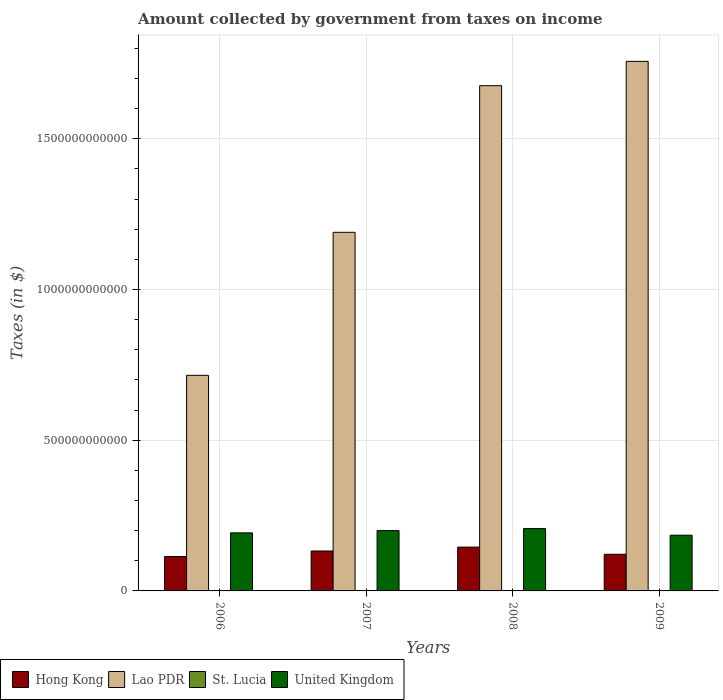How many groups of bars are there?
Offer a terse response. 4. How many bars are there on the 4th tick from the left?
Provide a short and direct response. 4. How many bars are there on the 1st tick from the right?
Make the answer very short. 4. What is the label of the 1st group of bars from the left?
Your answer should be compact. 2006. In how many cases, is the number of bars for a given year not equal to the number of legend labels?
Your answer should be compact. 0. What is the amount collected by government from taxes on income in Hong Kong in 2007?
Your answer should be compact. 1.32e+11. Across all years, what is the maximum amount collected by government from taxes on income in United Kingdom?
Make the answer very short. 2.07e+11. Across all years, what is the minimum amount collected by government from taxes on income in United Kingdom?
Provide a short and direct response. 1.85e+11. In which year was the amount collected by government from taxes on income in St. Lucia maximum?
Your response must be concise. 2009. In which year was the amount collected by government from taxes on income in United Kingdom minimum?
Your response must be concise. 2009. What is the total amount collected by government from taxes on income in Hong Kong in the graph?
Provide a succinct answer. 5.13e+11. What is the difference between the amount collected by government from taxes on income in United Kingdom in 2007 and that in 2008?
Keep it short and to the point. -6.88e+09. What is the difference between the amount collected by government from taxes on income in Lao PDR in 2007 and the amount collected by government from taxes on income in United Kingdom in 2009?
Make the answer very short. 1.00e+12. What is the average amount collected by government from taxes on income in Hong Kong per year?
Your answer should be very brief. 1.28e+11. In the year 2008, what is the difference between the amount collected by government from taxes on income in Lao PDR and amount collected by government from taxes on income in United Kingdom?
Provide a succinct answer. 1.47e+12. What is the ratio of the amount collected by government from taxes on income in Hong Kong in 2007 to that in 2009?
Your answer should be compact. 1.09. Is the amount collected by government from taxes on income in United Kingdom in 2006 less than that in 2007?
Your response must be concise. Yes. Is the difference between the amount collected by government from taxes on income in Lao PDR in 2006 and 2007 greater than the difference between the amount collected by government from taxes on income in United Kingdom in 2006 and 2007?
Ensure brevity in your answer.  No. What is the difference between the highest and the second highest amount collected by government from taxes on income in United Kingdom?
Your answer should be compact. 6.88e+09. What is the difference between the highest and the lowest amount collected by government from taxes on income in St. Lucia?
Your answer should be compact. 7.79e+07. In how many years, is the amount collected by government from taxes on income in St. Lucia greater than the average amount collected by government from taxes on income in St. Lucia taken over all years?
Your answer should be compact. 2. What does the 1st bar from the left in 2006 represents?
Provide a short and direct response. Hong Kong. What does the 2nd bar from the right in 2007 represents?
Offer a terse response. St. Lucia. Is it the case that in every year, the sum of the amount collected by government from taxes on income in St. Lucia and amount collected by government from taxes on income in United Kingdom is greater than the amount collected by government from taxes on income in Lao PDR?
Give a very brief answer. No. How many bars are there?
Offer a terse response. 16. How many years are there in the graph?
Your answer should be compact. 4. What is the difference between two consecutive major ticks on the Y-axis?
Give a very brief answer. 5.00e+11. Are the values on the major ticks of Y-axis written in scientific E-notation?
Keep it short and to the point. No. Does the graph contain grids?
Make the answer very short. Yes. Where does the legend appear in the graph?
Offer a terse response. Bottom left. How are the legend labels stacked?
Your answer should be compact. Horizontal. What is the title of the graph?
Your answer should be very brief. Amount collected by government from taxes on income. Does "Maldives" appear as one of the legend labels in the graph?
Your response must be concise. No. What is the label or title of the Y-axis?
Provide a succinct answer. Taxes (in $). What is the Taxes (in $) of Hong Kong in 2006?
Give a very brief answer. 1.14e+11. What is the Taxes (in $) in Lao PDR in 2006?
Give a very brief answer. 7.15e+11. What is the Taxes (in $) in St. Lucia in 2006?
Provide a short and direct response. 1.48e+08. What is the Taxes (in $) in United Kingdom in 2006?
Your response must be concise. 1.93e+11. What is the Taxes (in $) of Hong Kong in 2007?
Your answer should be very brief. 1.32e+11. What is the Taxes (in $) of Lao PDR in 2007?
Offer a very short reply. 1.19e+12. What is the Taxes (in $) of St. Lucia in 2007?
Provide a short and direct response. 1.77e+08. What is the Taxes (in $) in United Kingdom in 2007?
Keep it short and to the point. 2.00e+11. What is the Taxes (in $) in Hong Kong in 2008?
Your answer should be very brief. 1.45e+11. What is the Taxes (in $) of Lao PDR in 2008?
Keep it short and to the point. 1.68e+12. What is the Taxes (in $) in St. Lucia in 2008?
Keep it short and to the point. 2.26e+08. What is the Taxes (in $) of United Kingdom in 2008?
Ensure brevity in your answer.  2.07e+11. What is the Taxes (in $) in Hong Kong in 2009?
Ensure brevity in your answer.  1.22e+11. What is the Taxes (in $) in Lao PDR in 2009?
Your response must be concise. 1.76e+12. What is the Taxes (in $) in St. Lucia in 2009?
Ensure brevity in your answer.  2.26e+08. What is the Taxes (in $) of United Kingdom in 2009?
Your answer should be compact. 1.85e+11. Across all years, what is the maximum Taxes (in $) of Hong Kong?
Your answer should be compact. 1.45e+11. Across all years, what is the maximum Taxes (in $) in Lao PDR?
Your response must be concise. 1.76e+12. Across all years, what is the maximum Taxes (in $) of St. Lucia?
Give a very brief answer. 2.26e+08. Across all years, what is the maximum Taxes (in $) in United Kingdom?
Offer a very short reply. 2.07e+11. Across all years, what is the minimum Taxes (in $) in Hong Kong?
Offer a very short reply. 1.14e+11. Across all years, what is the minimum Taxes (in $) of Lao PDR?
Keep it short and to the point. 7.15e+11. Across all years, what is the minimum Taxes (in $) in St. Lucia?
Provide a short and direct response. 1.48e+08. Across all years, what is the minimum Taxes (in $) in United Kingdom?
Offer a terse response. 1.85e+11. What is the total Taxes (in $) in Hong Kong in the graph?
Provide a short and direct response. 5.13e+11. What is the total Taxes (in $) in Lao PDR in the graph?
Provide a succinct answer. 5.34e+12. What is the total Taxes (in $) of St. Lucia in the graph?
Keep it short and to the point. 7.77e+08. What is the total Taxes (in $) of United Kingdom in the graph?
Offer a very short reply. 7.84e+11. What is the difference between the Taxes (in $) of Hong Kong in 2006 and that in 2007?
Your response must be concise. -1.84e+1. What is the difference between the Taxes (in $) of Lao PDR in 2006 and that in 2007?
Provide a succinct answer. -4.74e+11. What is the difference between the Taxes (in $) of St. Lucia in 2006 and that in 2007?
Provide a succinct answer. -2.82e+07. What is the difference between the Taxes (in $) of United Kingdom in 2006 and that in 2007?
Give a very brief answer. -7.44e+09. What is the difference between the Taxes (in $) in Hong Kong in 2006 and that in 2008?
Make the answer very short. -3.12e+1. What is the difference between the Taxes (in $) of Lao PDR in 2006 and that in 2008?
Ensure brevity in your answer.  -9.61e+11. What is the difference between the Taxes (in $) in St. Lucia in 2006 and that in 2008?
Ensure brevity in your answer.  -7.73e+07. What is the difference between the Taxes (in $) of United Kingdom in 2006 and that in 2008?
Provide a short and direct response. -1.43e+1. What is the difference between the Taxes (in $) in Hong Kong in 2006 and that in 2009?
Make the answer very short. -7.44e+09. What is the difference between the Taxes (in $) in Lao PDR in 2006 and that in 2009?
Provide a succinct answer. -1.04e+12. What is the difference between the Taxes (in $) of St. Lucia in 2006 and that in 2009?
Make the answer very short. -7.79e+07. What is the difference between the Taxes (in $) of United Kingdom in 2006 and that in 2009?
Ensure brevity in your answer.  7.80e+09. What is the difference between the Taxes (in $) of Hong Kong in 2007 and that in 2008?
Keep it short and to the point. -1.28e+1. What is the difference between the Taxes (in $) in Lao PDR in 2007 and that in 2008?
Make the answer very short. -4.86e+11. What is the difference between the Taxes (in $) in St. Lucia in 2007 and that in 2008?
Provide a succinct answer. -4.91e+07. What is the difference between the Taxes (in $) in United Kingdom in 2007 and that in 2008?
Provide a short and direct response. -6.88e+09. What is the difference between the Taxes (in $) of Hong Kong in 2007 and that in 2009?
Your response must be concise. 1.10e+1. What is the difference between the Taxes (in $) in Lao PDR in 2007 and that in 2009?
Your response must be concise. -5.67e+11. What is the difference between the Taxes (in $) in St. Lucia in 2007 and that in 2009?
Provide a succinct answer. -4.97e+07. What is the difference between the Taxes (in $) in United Kingdom in 2007 and that in 2009?
Your response must be concise. 1.52e+1. What is the difference between the Taxes (in $) in Hong Kong in 2008 and that in 2009?
Give a very brief answer. 2.38e+1. What is the difference between the Taxes (in $) in Lao PDR in 2008 and that in 2009?
Make the answer very short. -8.07e+1. What is the difference between the Taxes (in $) of St. Lucia in 2008 and that in 2009?
Provide a succinct answer. -6.00e+05. What is the difference between the Taxes (in $) in United Kingdom in 2008 and that in 2009?
Your response must be concise. 2.21e+1. What is the difference between the Taxes (in $) in Hong Kong in 2006 and the Taxes (in $) in Lao PDR in 2007?
Provide a short and direct response. -1.08e+12. What is the difference between the Taxes (in $) of Hong Kong in 2006 and the Taxes (in $) of St. Lucia in 2007?
Ensure brevity in your answer.  1.14e+11. What is the difference between the Taxes (in $) in Hong Kong in 2006 and the Taxes (in $) in United Kingdom in 2007?
Provide a succinct answer. -8.60e+1. What is the difference between the Taxes (in $) of Lao PDR in 2006 and the Taxes (in $) of St. Lucia in 2007?
Offer a terse response. 7.15e+11. What is the difference between the Taxes (in $) in Lao PDR in 2006 and the Taxes (in $) in United Kingdom in 2007?
Your answer should be very brief. 5.15e+11. What is the difference between the Taxes (in $) of St. Lucia in 2006 and the Taxes (in $) of United Kingdom in 2007?
Make the answer very short. -2.00e+11. What is the difference between the Taxes (in $) of Hong Kong in 2006 and the Taxes (in $) of Lao PDR in 2008?
Your answer should be compact. -1.56e+12. What is the difference between the Taxes (in $) of Hong Kong in 2006 and the Taxes (in $) of St. Lucia in 2008?
Keep it short and to the point. 1.14e+11. What is the difference between the Taxes (in $) in Hong Kong in 2006 and the Taxes (in $) in United Kingdom in 2008?
Offer a terse response. -9.28e+1. What is the difference between the Taxes (in $) in Lao PDR in 2006 and the Taxes (in $) in St. Lucia in 2008?
Your answer should be compact. 7.15e+11. What is the difference between the Taxes (in $) of Lao PDR in 2006 and the Taxes (in $) of United Kingdom in 2008?
Your response must be concise. 5.08e+11. What is the difference between the Taxes (in $) in St. Lucia in 2006 and the Taxes (in $) in United Kingdom in 2008?
Offer a very short reply. -2.07e+11. What is the difference between the Taxes (in $) of Hong Kong in 2006 and the Taxes (in $) of Lao PDR in 2009?
Make the answer very short. -1.64e+12. What is the difference between the Taxes (in $) in Hong Kong in 2006 and the Taxes (in $) in St. Lucia in 2009?
Provide a succinct answer. 1.14e+11. What is the difference between the Taxes (in $) of Hong Kong in 2006 and the Taxes (in $) of United Kingdom in 2009?
Keep it short and to the point. -7.07e+1. What is the difference between the Taxes (in $) of Lao PDR in 2006 and the Taxes (in $) of St. Lucia in 2009?
Provide a short and direct response. 7.15e+11. What is the difference between the Taxes (in $) of Lao PDR in 2006 and the Taxes (in $) of United Kingdom in 2009?
Make the answer very short. 5.30e+11. What is the difference between the Taxes (in $) of St. Lucia in 2006 and the Taxes (in $) of United Kingdom in 2009?
Keep it short and to the point. -1.85e+11. What is the difference between the Taxes (in $) in Hong Kong in 2007 and the Taxes (in $) in Lao PDR in 2008?
Ensure brevity in your answer.  -1.54e+12. What is the difference between the Taxes (in $) in Hong Kong in 2007 and the Taxes (in $) in St. Lucia in 2008?
Your answer should be very brief. 1.32e+11. What is the difference between the Taxes (in $) of Hong Kong in 2007 and the Taxes (in $) of United Kingdom in 2008?
Keep it short and to the point. -7.44e+1. What is the difference between the Taxes (in $) of Lao PDR in 2007 and the Taxes (in $) of St. Lucia in 2008?
Offer a terse response. 1.19e+12. What is the difference between the Taxes (in $) of Lao PDR in 2007 and the Taxes (in $) of United Kingdom in 2008?
Make the answer very short. 9.83e+11. What is the difference between the Taxes (in $) of St. Lucia in 2007 and the Taxes (in $) of United Kingdom in 2008?
Provide a succinct answer. -2.07e+11. What is the difference between the Taxes (in $) of Hong Kong in 2007 and the Taxes (in $) of Lao PDR in 2009?
Provide a short and direct response. -1.62e+12. What is the difference between the Taxes (in $) in Hong Kong in 2007 and the Taxes (in $) in St. Lucia in 2009?
Ensure brevity in your answer.  1.32e+11. What is the difference between the Taxes (in $) in Hong Kong in 2007 and the Taxes (in $) in United Kingdom in 2009?
Make the answer very short. -5.23e+1. What is the difference between the Taxes (in $) of Lao PDR in 2007 and the Taxes (in $) of St. Lucia in 2009?
Offer a very short reply. 1.19e+12. What is the difference between the Taxes (in $) in Lao PDR in 2007 and the Taxes (in $) in United Kingdom in 2009?
Make the answer very short. 1.00e+12. What is the difference between the Taxes (in $) in St. Lucia in 2007 and the Taxes (in $) in United Kingdom in 2009?
Your answer should be compact. -1.85e+11. What is the difference between the Taxes (in $) in Hong Kong in 2008 and the Taxes (in $) in Lao PDR in 2009?
Make the answer very short. -1.61e+12. What is the difference between the Taxes (in $) in Hong Kong in 2008 and the Taxes (in $) in St. Lucia in 2009?
Your response must be concise. 1.45e+11. What is the difference between the Taxes (in $) of Hong Kong in 2008 and the Taxes (in $) of United Kingdom in 2009?
Make the answer very short. -3.95e+1. What is the difference between the Taxes (in $) of Lao PDR in 2008 and the Taxes (in $) of St. Lucia in 2009?
Keep it short and to the point. 1.68e+12. What is the difference between the Taxes (in $) in Lao PDR in 2008 and the Taxes (in $) in United Kingdom in 2009?
Your answer should be very brief. 1.49e+12. What is the difference between the Taxes (in $) of St. Lucia in 2008 and the Taxes (in $) of United Kingdom in 2009?
Your answer should be compact. -1.85e+11. What is the average Taxes (in $) in Hong Kong per year?
Provide a succinct answer. 1.28e+11. What is the average Taxes (in $) in Lao PDR per year?
Make the answer very short. 1.33e+12. What is the average Taxes (in $) in St. Lucia per year?
Your answer should be very brief. 1.94e+08. What is the average Taxes (in $) in United Kingdom per year?
Make the answer very short. 1.96e+11. In the year 2006, what is the difference between the Taxes (in $) in Hong Kong and Taxes (in $) in Lao PDR?
Your answer should be compact. -6.01e+11. In the year 2006, what is the difference between the Taxes (in $) in Hong Kong and Taxes (in $) in St. Lucia?
Your response must be concise. 1.14e+11. In the year 2006, what is the difference between the Taxes (in $) in Hong Kong and Taxes (in $) in United Kingdom?
Your response must be concise. -7.85e+1. In the year 2006, what is the difference between the Taxes (in $) in Lao PDR and Taxes (in $) in St. Lucia?
Offer a terse response. 7.15e+11. In the year 2006, what is the difference between the Taxes (in $) of Lao PDR and Taxes (in $) of United Kingdom?
Make the answer very short. 5.23e+11. In the year 2006, what is the difference between the Taxes (in $) in St. Lucia and Taxes (in $) in United Kingdom?
Keep it short and to the point. -1.92e+11. In the year 2007, what is the difference between the Taxes (in $) in Hong Kong and Taxes (in $) in Lao PDR?
Your answer should be compact. -1.06e+12. In the year 2007, what is the difference between the Taxes (in $) of Hong Kong and Taxes (in $) of St. Lucia?
Your answer should be compact. 1.32e+11. In the year 2007, what is the difference between the Taxes (in $) in Hong Kong and Taxes (in $) in United Kingdom?
Offer a very short reply. -6.76e+1. In the year 2007, what is the difference between the Taxes (in $) of Lao PDR and Taxes (in $) of St. Lucia?
Provide a short and direct response. 1.19e+12. In the year 2007, what is the difference between the Taxes (in $) of Lao PDR and Taxes (in $) of United Kingdom?
Your response must be concise. 9.90e+11. In the year 2007, what is the difference between the Taxes (in $) of St. Lucia and Taxes (in $) of United Kingdom?
Your response must be concise. -2.00e+11. In the year 2008, what is the difference between the Taxes (in $) in Hong Kong and Taxes (in $) in Lao PDR?
Your answer should be compact. -1.53e+12. In the year 2008, what is the difference between the Taxes (in $) of Hong Kong and Taxes (in $) of St. Lucia?
Provide a succinct answer. 1.45e+11. In the year 2008, what is the difference between the Taxes (in $) in Hong Kong and Taxes (in $) in United Kingdom?
Give a very brief answer. -6.16e+1. In the year 2008, what is the difference between the Taxes (in $) of Lao PDR and Taxes (in $) of St. Lucia?
Your answer should be very brief. 1.68e+12. In the year 2008, what is the difference between the Taxes (in $) of Lao PDR and Taxes (in $) of United Kingdom?
Your answer should be very brief. 1.47e+12. In the year 2008, what is the difference between the Taxes (in $) in St. Lucia and Taxes (in $) in United Kingdom?
Your answer should be very brief. -2.07e+11. In the year 2009, what is the difference between the Taxes (in $) in Hong Kong and Taxes (in $) in Lao PDR?
Provide a succinct answer. -1.64e+12. In the year 2009, what is the difference between the Taxes (in $) of Hong Kong and Taxes (in $) of St. Lucia?
Ensure brevity in your answer.  1.21e+11. In the year 2009, what is the difference between the Taxes (in $) in Hong Kong and Taxes (in $) in United Kingdom?
Offer a very short reply. -6.33e+1. In the year 2009, what is the difference between the Taxes (in $) of Lao PDR and Taxes (in $) of St. Lucia?
Your answer should be very brief. 1.76e+12. In the year 2009, what is the difference between the Taxes (in $) in Lao PDR and Taxes (in $) in United Kingdom?
Give a very brief answer. 1.57e+12. In the year 2009, what is the difference between the Taxes (in $) in St. Lucia and Taxes (in $) in United Kingdom?
Ensure brevity in your answer.  -1.85e+11. What is the ratio of the Taxes (in $) in Hong Kong in 2006 to that in 2007?
Provide a succinct answer. 0.86. What is the ratio of the Taxes (in $) of Lao PDR in 2006 to that in 2007?
Give a very brief answer. 0.6. What is the ratio of the Taxes (in $) in St. Lucia in 2006 to that in 2007?
Make the answer very short. 0.84. What is the ratio of the Taxes (in $) of United Kingdom in 2006 to that in 2007?
Your response must be concise. 0.96. What is the ratio of the Taxes (in $) in Hong Kong in 2006 to that in 2008?
Offer a very short reply. 0.78. What is the ratio of the Taxes (in $) of Lao PDR in 2006 to that in 2008?
Give a very brief answer. 0.43. What is the ratio of the Taxes (in $) in St. Lucia in 2006 to that in 2008?
Your answer should be very brief. 0.66. What is the ratio of the Taxes (in $) of United Kingdom in 2006 to that in 2008?
Offer a terse response. 0.93. What is the ratio of the Taxes (in $) in Hong Kong in 2006 to that in 2009?
Make the answer very short. 0.94. What is the ratio of the Taxes (in $) in Lao PDR in 2006 to that in 2009?
Provide a short and direct response. 0.41. What is the ratio of the Taxes (in $) of St. Lucia in 2006 to that in 2009?
Ensure brevity in your answer.  0.66. What is the ratio of the Taxes (in $) in United Kingdom in 2006 to that in 2009?
Make the answer very short. 1.04. What is the ratio of the Taxes (in $) in Hong Kong in 2007 to that in 2008?
Keep it short and to the point. 0.91. What is the ratio of the Taxes (in $) in Lao PDR in 2007 to that in 2008?
Offer a terse response. 0.71. What is the ratio of the Taxes (in $) of St. Lucia in 2007 to that in 2008?
Offer a very short reply. 0.78. What is the ratio of the Taxes (in $) in United Kingdom in 2007 to that in 2008?
Provide a short and direct response. 0.97. What is the ratio of the Taxes (in $) of Hong Kong in 2007 to that in 2009?
Provide a succinct answer. 1.09. What is the ratio of the Taxes (in $) in Lao PDR in 2007 to that in 2009?
Make the answer very short. 0.68. What is the ratio of the Taxes (in $) of St. Lucia in 2007 to that in 2009?
Ensure brevity in your answer.  0.78. What is the ratio of the Taxes (in $) in United Kingdom in 2007 to that in 2009?
Keep it short and to the point. 1.08. What is the ratio of the Taxes (in $) in Hong Kong in 2008 to that in 2009?
Make the answer very short. 1.2. What is the ratio of the Taxes (in $) of Lao PDR in 2008 to that in 2009?
Provide a short and direct response. 0.95. What is the ratio of the Taxes (in $) of St. Lucia in 2008 to that in 2009?
Offer a very short reply. 1. What is the ratio of the Taxes (in $) in United Kingdom in 2008 to that in 2009?
Make the answer very short. 1.12. What is the difference between the highest and the second highest Taxes (in $) in Hong Kong?
Offer a very short reply. 1.28e+1. What is the difference between the highest and the second highest Taxes (in $) of Lao PDR?
Provide a short and direct response. 8.07e+1. What is the difference between the highest and the second highest Taxes (in $) of St. Lucia?
Provide a succinct answer. 6.00e+05. What is the difference between the highest and the second highest Taxes (in $) of United Kingdom?
Provide a succinct answer. 6.88e+09. What is the difference between the highest and the lowest Taxes (in $) in Hong Kong?
Your response must be concise. 3.12e+1. What is the difference between the highest and the lowest Taxes (in $) of Lao PDR?
Your answer should be very brief. 1.04e+12. What is the difference between the highest and the lowest Taxes (in $) in St. Lucia?
Provide a short and direct response. 7.79e+07. What is the difference between the highest and the lowest Taxes (in $) in United Kingdom?
Offer a very short reply. 2.21e+1. 